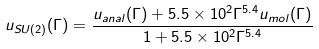Convert formula to latex. <formula><loc_0><loc_0><loc_500><loc_500>u _ { S U ( 2 ) } ( \Gamma ) = \frac { u _ { a n a l } ( \Gamma ) + 5 . 5 \times 1 0 ^ { 2 } \Gamma ^ { 5 . 4 } u _ { m o l } ( \Gamma ) } { 1 + 5 . 5 \times 1 0 ^ { 2 } \Gamma ^ { 5 . 4 } }</formula> 